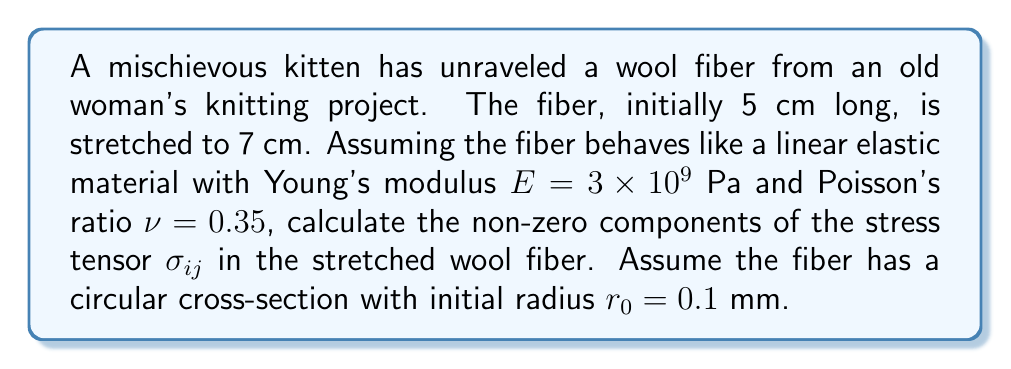Can you solve this math problem? 1. Calculate the engineering strain $\varepsilon$:
   $$\varepsilon = \frac{\Delta L}{L_0} = \frac{7 \text{ cm} - 5 \text{ cm}}{5 \text{ cm}} = 0.4$$

2. For a uniaxial stress state, the only non-zero stress component is $\sigma_{11}$ (along the fiber axis). Calculate $\sigma_{11}$ using Hooke's law:
   $$\sigma_{11} = E \varepsilon = (3 \times 10^9 \text{ Pa})(0.4) = 1.2 \times 10^9 \text{ Pa}$$

3. The transverse strains $\varepsilon_{22}$ and $\varepsilon_{33}$ are related to $\varepsilon_{11}$ by Poisson's ratio:
   $$\varepsilon_{22} = \varepsilon_{33} = -\nu \varepsilon_{11} = -0.35(0.4) = -0.14$$

4. Calculate the new radius $r$ of the fiber:
   $$r = r_0(1 + \varepsilon_{22}) = 0.1 \text{ mm}(1 - 0.14) = 0.086 \text{ mm}$$

5. The stress tensor in cylindrical coordinates $(r, \theta, z)$ is:
   $$\sigma_{ij} = \begin{pmatrix}
   0 & 0 & 0 \\
   0 & 0 & 0 \\
   0 & 0 & \sigma_{zz}
   \end{pmatrix}$$

   Where $\sigma_{zz} = \sigma_{11} = 1.2 \times 10^9 \text{ Pa}$
Answer: $\sigma_{zz} = 1.2 \times 10^9 \text{ Pa}$, all other components are zero. 